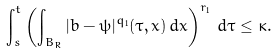<formula> <loc_0><loc_0><loc_500><loc_500>\int _ { s } ^ { t } \left ( \int _ { B _ { R } } | b - \psi | ^ { q _ { 1 } } ( \tau , x ) \, d x \right ) ^ { r _ { 1 } } \, d \tau \leq \kappa .</formula> 